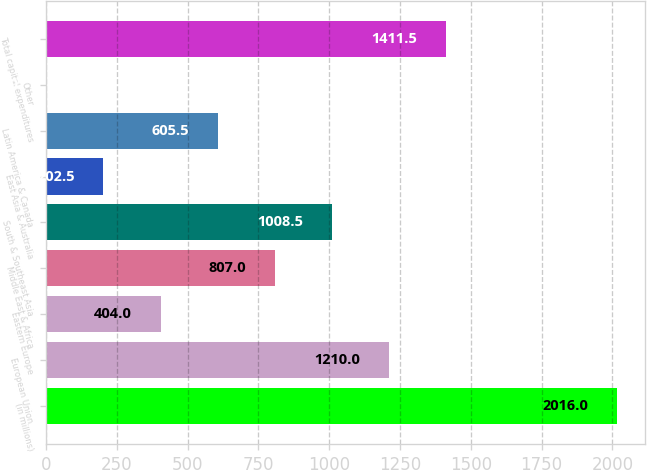Convert chart. <chart><loc_0><loc_0><loc_500><loc_500><bar_chart><fcel>(in millions)<fcel>European Union<fcel>Eastern Europe<fcel>Middle East & Africa<fcel>South & Southeast Asia<fcel>East Asia & Australia<fcel>Latin America & Canada<fcel>Other<fcel>Total capital expenditures<nl><fcel>2016<fcel>1210<fcel>404<fcel>807<fcel>1008.5<fcel>202.5<fcel>605.5<fcel>1<fcel>1411.5<nl></chart> 